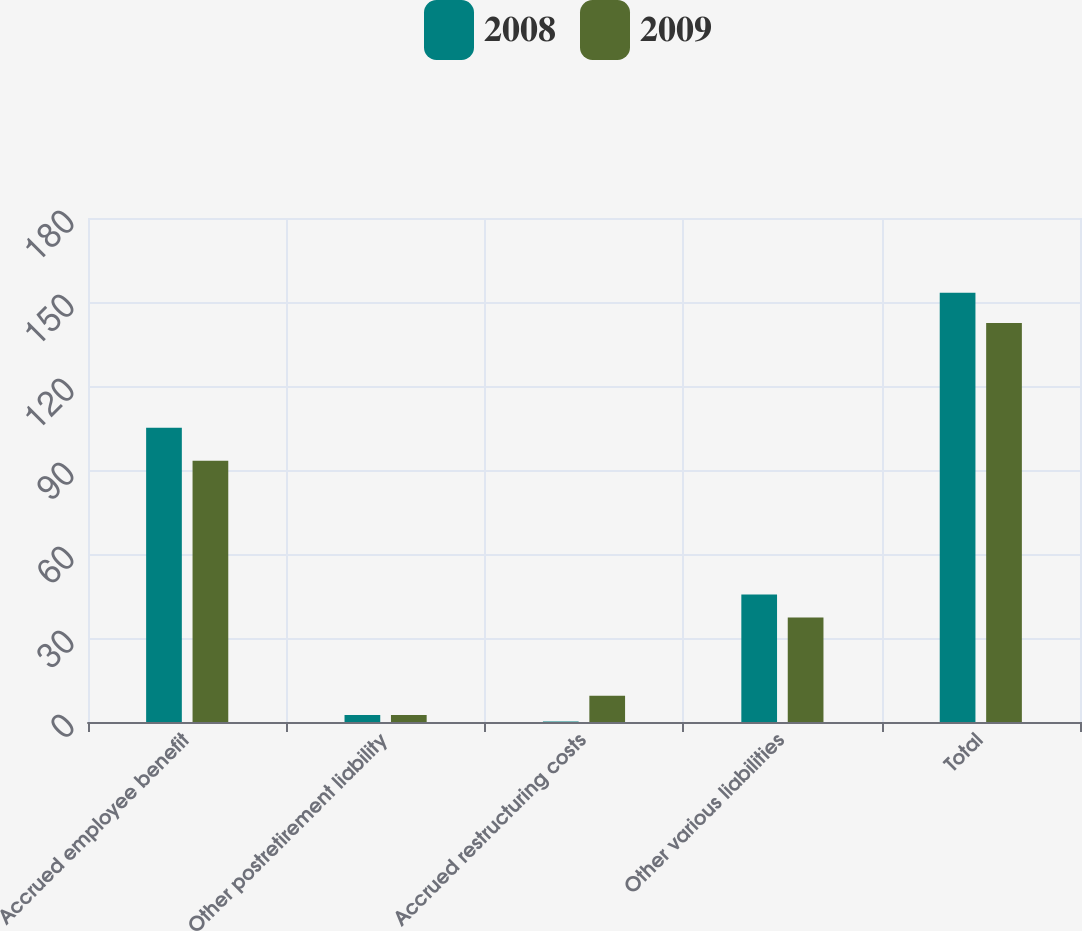Convert chart. <chart><loc_0><loc_0><loc_500><loc_500><stacked_bar_chart><ecel><fcel>Accrued employee benefit<fcel>Other postretirement liability<fcel>Accrued restructuring costs<fcel>Other various liabilities<fcel>Total<nl><fcel>2008<fcel>105.1<fcel>2.5<fcel>0.2<fcel>45.5<fcel>153.3<nl><fcel>2009<fcel>93.3<fcel>2.5<fcel>9.4<fcel>37.3<fcel>142.5<nl></chart> 